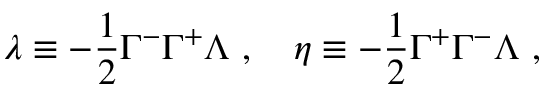Convert formula to latex. <formula><loc_0><loc_0><loc_500><loc_500>\lambda \equiv - \frac { 1 } { 2 } \Gamma ^ { - } \Gamma ^ { + } \Lambda , \eta \equiv - \frac { 1 } { 2 } \Gamma ^ { + } \Gamma ^ { - } \Lambda ,</formula> 